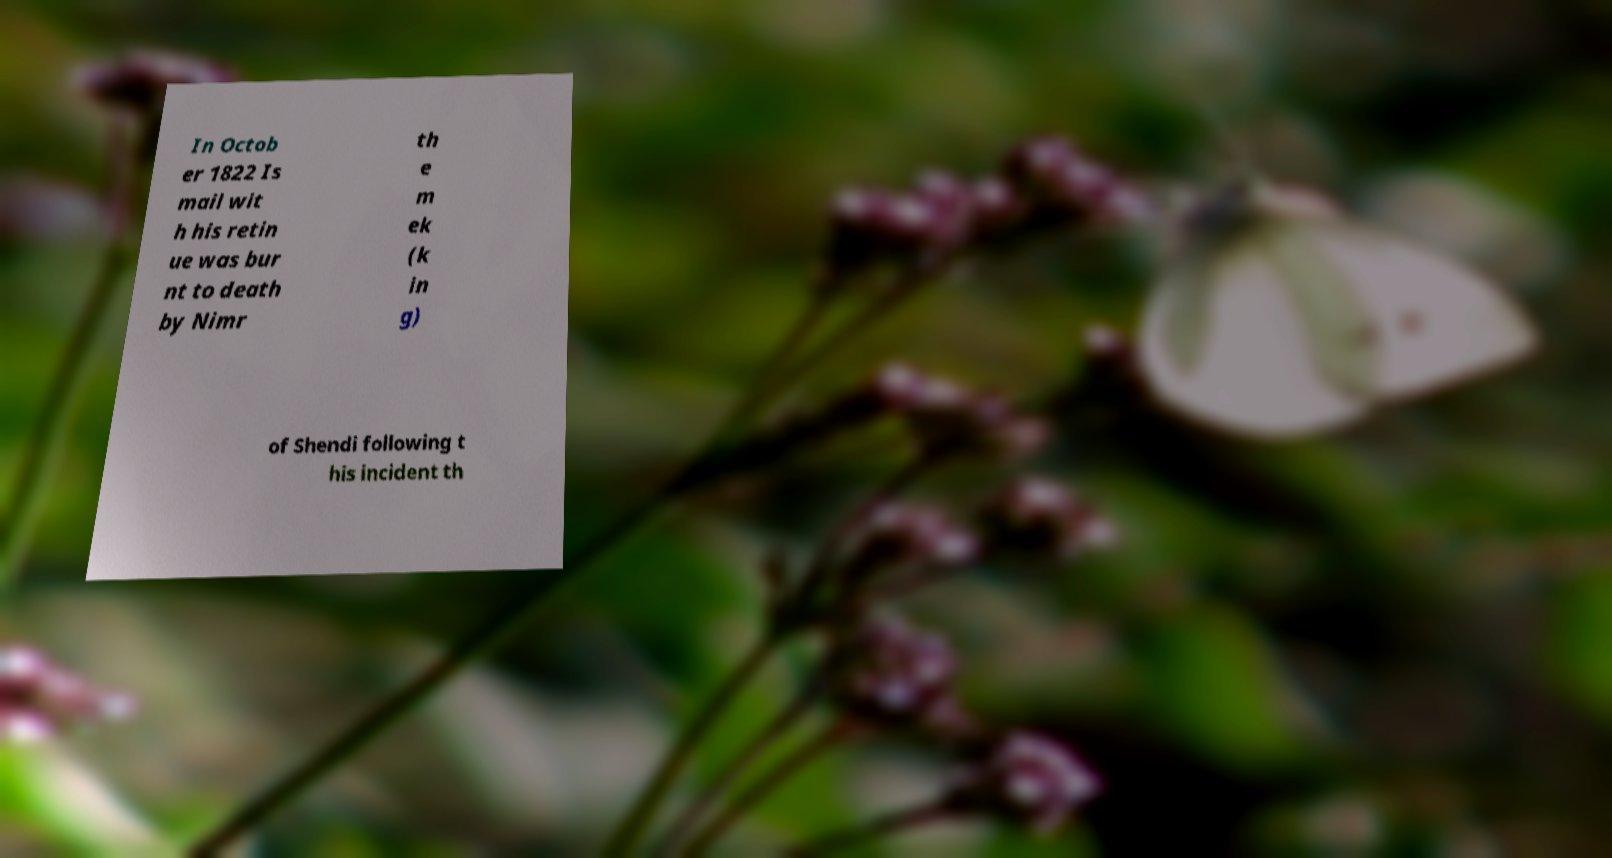I need the written content from this picture converted into text. Can you do that? In Octob er 1822 Is mail wit h his retin ue was bur nt to death by Nimr th e m ek (k in g) of Shendi following t his incident th 